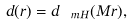<formula> <loc_0><loc_0><loc_500><loc_500>d ( r ) = d _ { \ m H } ( M r ) ,</formula> 